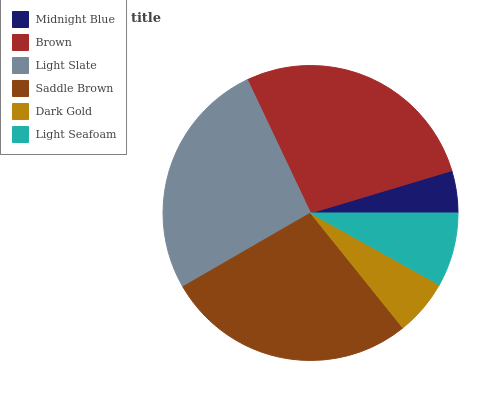Is Midnight Blue the minimum?
Answer yes or no. Yes. Is Saddle Brown the maximum?
Answer yes or no. Yes. Is Brown the minimum?
Answer yes or no. No. Is Brown the maximum?
Answer yes or no. No. Is Brown greater than Midnight Blue?
Answer yes or no. Yes. Is Midnight Blue less than Brown?
Answer yes or no. Yes. Is Midnight Blue greater than Brown?
Answer yes or no. No. Is Brown less than Midnight Blue?
Answer yes or no. No. Is Light Slate the high median?
Answer yes or no. Yes. Is Light Seafoam the low median?
Answer yes or no. Yes. Is Saddle Brown the high median?
Answer yes or no. No. Is Midnight Blue the low median?
Answer yes or no. No. 